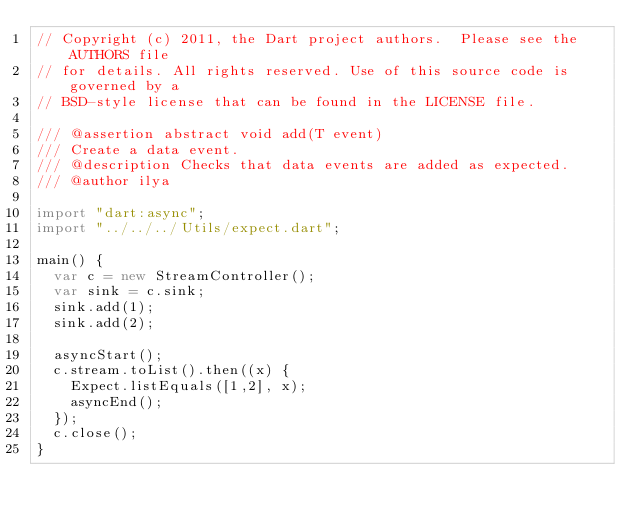Convert code to text. <code><loc_0><loc_0><loc_500><loc_500><_Dart_>// Copyright (c) 2011, the Dart project authors.  Please see the AUTHORS file
// for details. All rights reserved. Use of this source code is governed by a
// BSD-style license that can be found in the LICENSE file.

/// @assertion abstract void add(T event)
/// Create a data event.
/// @description Checks that data events are added as expected.
/// @author ilya

import "dart:async";
import "../../../Utils/expect.dart";

main() {
  var c = new StreamController();
  var sink = c.sink;
  sink.add(1);
  sink.add(2);

  asyncStart();
  c.stream.toList().then((x) {
    Expect.listEquals([1,2], x);
    asyncEnd();
  });
  c.close();
}
</code> 